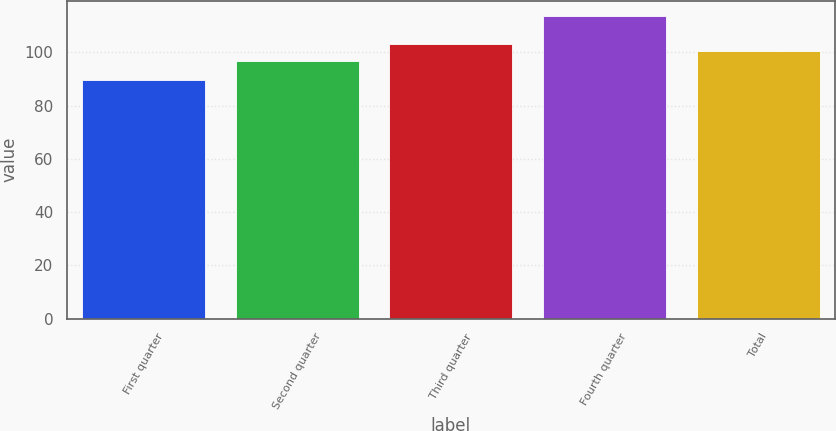Convert chart. <chart><loc_0><loc_0><loc_500><loc_500><bar_chart><fcel>First quarter<fcel>Second quarter<fcel>Third quarter<fcel>Fourth quarter<fcel>Total<nl><fcel>89.43<fcel>96.84<fcel>103.08<fcel>113.77<fcel>100.65<nl></chart> 